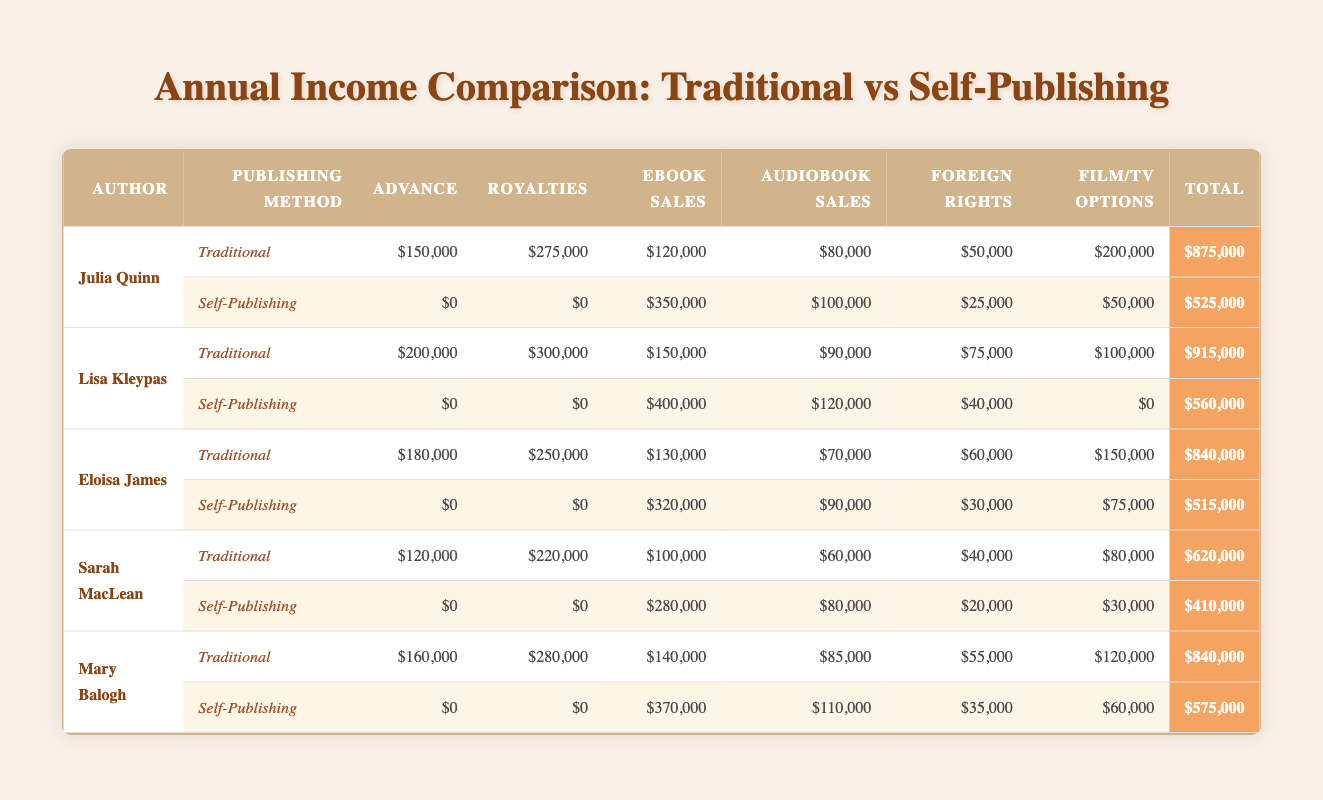What is the total income for Julia Quinn from Traditional Publishing? To find Julia Quinn's total income from Traditional Publishing, we need to add together all of her income categories: Advance ($150,000) + Royalties ($275,000) + eBook Sales ($120,000) + Audiobook Sales ($80,000) + Foreign Rights ($50,000) + Film/TV Options ($200,000) = $875,000.
Answer: 875000 What is the income difference between Lisa Kleypas's Traditional and Self-Publishing methods? To find the income difference, we subtract the total income of Self-Publishing from Traditional Publishing. For Lisa Kleypas: Traditional total is $915,000 and Self-Publishing total is $560,000. The difference is $915,000 - $560,000 = $355,000.
Answer: 355000 Did Eloisa James earn any advance from Self-Publishing? Looking at Eloisa James's Self-Publishing data, her Advance income is listed as $0, indicating she did not earn any advance from this publishing method.
Answer: No Which author had the highest total income from Traditional Publishing? We compare total incomes for Traditional Publishing: Julia Quinn ($875,000), Lisa Kleypas ($915,000), Eloisa James ($840,000), Sarah MacLean ($620,000), and Mary Balogh ($840,000). Lisa Kleypas has the highest total income at $915,000.
Answer: Lisa Kleypas What is the average eBook Sales income for the authors listed in Traditional Publishing? To find the average eBook Sales income, we first add the eBook Sales values: ($120,000 + $150,000 + $130,000 + $100,000 + $140,000) = $640,000. There are 5 authors, so the average is $640,000 / 5 = $128,000.
Answer: 128000 Which publishing method did Sarah MacLean earn more from, Traditional or Self-Publishing? Sarah MacLean's total from Traditional Publishing is $620,000 and from Self-Publishing is $410,000. Since $620,000 is greater than $410,000, she earned more from Traditional Publishing.
Answer: Traditional Publishing What is the combined income from Film/TV Options for all authors in Traditional Publishing? We need to sum the Film/TV Options income for all authors in Traditional Publishing: Julia Quinn ($200,000) + Lisa Kleypas ($100,000) + Eloisa James ($150,000) + Sarah MacLean ($80,000) + Mary Balogh ($120,000) = $650,000
Answer: 650000 Is it true that all authors earned zero in Advancements from Self-Publishing? By reviewing the data, all authors listed have an Advance income of $0 from Self-Publishing, thus confirming the statement is true.
Answer: Yes 